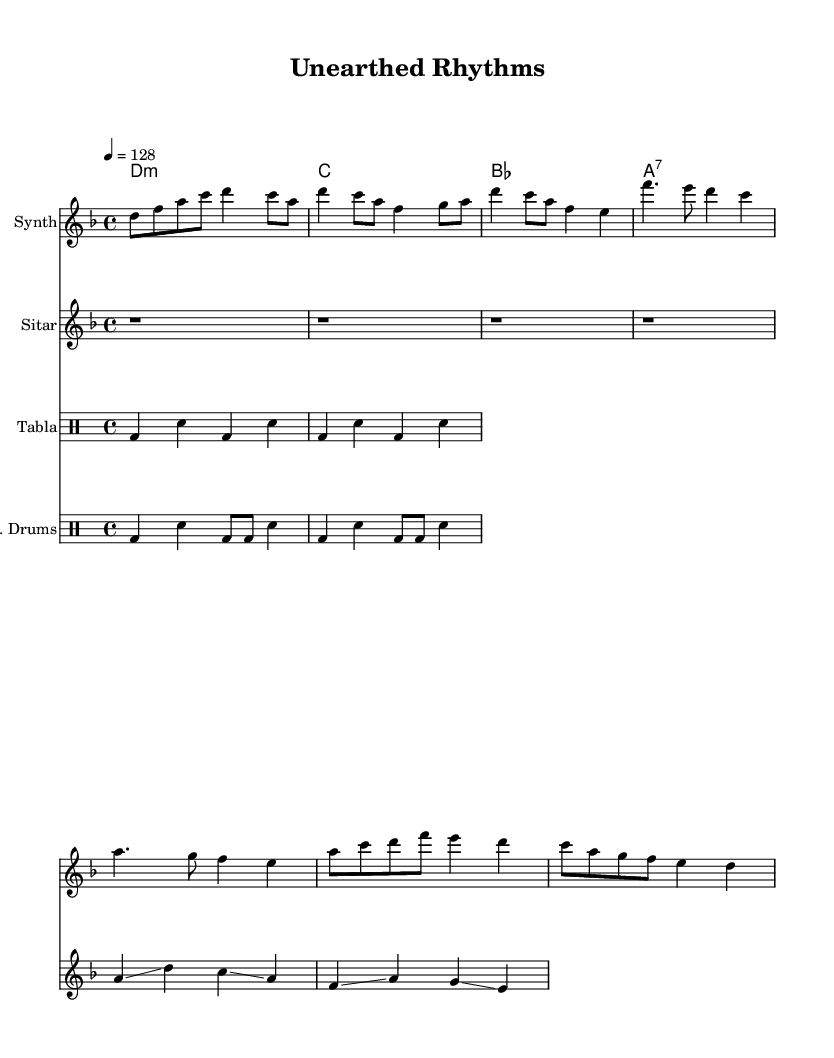What is the key signature of this music? The key signature is indicated by the 'key' command, which specifies D minor. This means the scale starts on D and includes one flat (B flat).
Answer: D minor What is the time signature of this music? The time signature is represented by the 'time' command, which is 4/4. This indicates that there are four beats per measure, and the quarter note gets one beat.
Answer: 4/4 What is the tempo marking for this piece? The tempo marking is shown in the 'tempo' command, which is labeled as 4 = 128. This indicates that there are 128 beats per minute.
Answer: 128 How many measures are present in the sitar part? Counting the number of measures in the sitar part shows that there are 4 measures of rests followed by 2 measures of melodic content. Adding these gives a total of 6 measures.
Answer: 6 Which instrument is primarily providing the melody in this piece? The primary melody line is provided under the 'new Staff' labeled as "Synth." This part carries the main melodic content and is distinct from the harmony and rhythmic elements.
Answer: Synth How is the rhythm structured in the tabla part? The tabla rhythm includes a repeated pattern of bass drum (bd) and snare (sn) notes for each measure, alternating consistently throughout. This gives it a structured, cyclic rhythmic feel typical of traditional Indian music.
Answer: Cyclic What is the chord progression indicated in the harmonies? The chord progression indicated is D minor, C major, B flat major, and A7 major (D:m, c, bes, a:7). This progression provides the harmonic foundation over which the melody and rhythm interact.
Answer: D minor, C major, B flat major, A7 